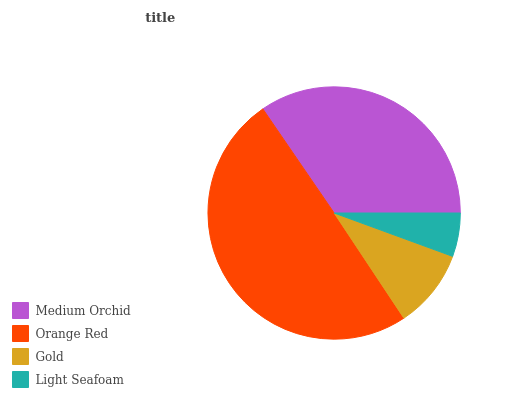Is Light Seafoam the minimum?
Answer yes or no. Yes. Is Orange Red the maximum?
Answer yes or no. Yes. Is Gold the minimum?
Answer yes or no. No. Is Gold the maximum?
Answer yes or no. No. Is Orange Red greater than Gold?
Answer yes or no. Yes. Is Gold less than Orange Red?
Answer yes or no. Yes. Is Gold greater than Orange Red?
Answer yes or no. No. Is Orange Red less than Gold?
Answer yes or no. No. Is Medium Orchid the high median?
Answer yes or no. Yes. Is Gold the low median?
Answer yes or no. Yes. Is Orange Red the high median?
Answer yes or no. No. Is Medium Orchid the low median?
Answer yes or no. No. 